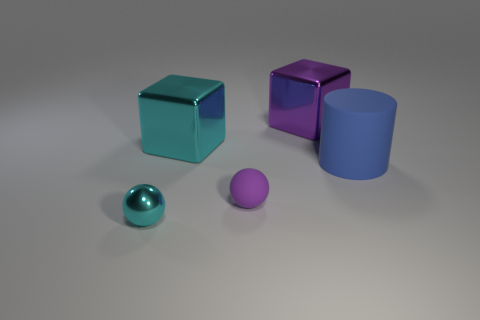What material is the large cube that is the same color as the tiny rubber ball?
Your response must be concise. Metal. Is the material of the cylinder the same as the small purple sphere?
Your response must be concise. Yes. There is a cube to the right of the cyan metal object to the right of the tiny cyan shiny ball; what number of big cylinders are in front of it?
Your answer should be very brief. 1. Is there a thing made of the same material as the purple block?
Offer a terse response. Yes. Is the number of purple balls less than the number of spheres?
Ensure brevity in your answer.  Yes. There is a metal block that is left of the big purple shiny block; does it have the same color as the tiny shiny thing?
Make the answer very short. Yes. What is the material of the big cube that is to the left of the big shiny thing that is behind the cyan thing that is behind the blue cylinder?
Make the answer very short. Metal. Are there any metal objects of the same color as the tiny matte ball?
Your answer should be very brief. Yes. Are there fewer small cyan metal things left of the cyan shiny sphere than small things?
Offer a very short reply. Yes. Is the size of the cyan metal object behind the rubber ball the same as the large purple cube?
Offer a very short reply. Yes. 